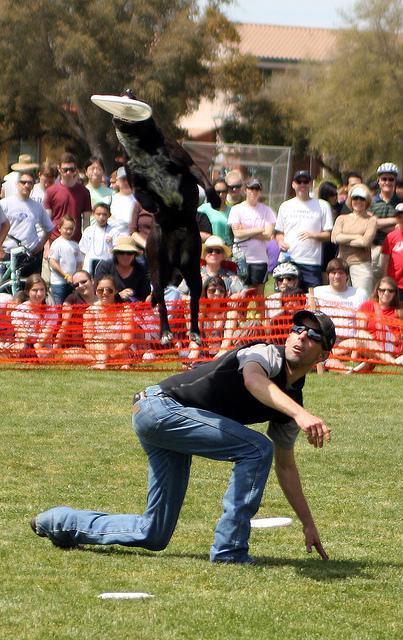How many people are in the photo?
Give a very brief answer. 10. How many dogs are in the picture?
Give a very brief answer. 1. 